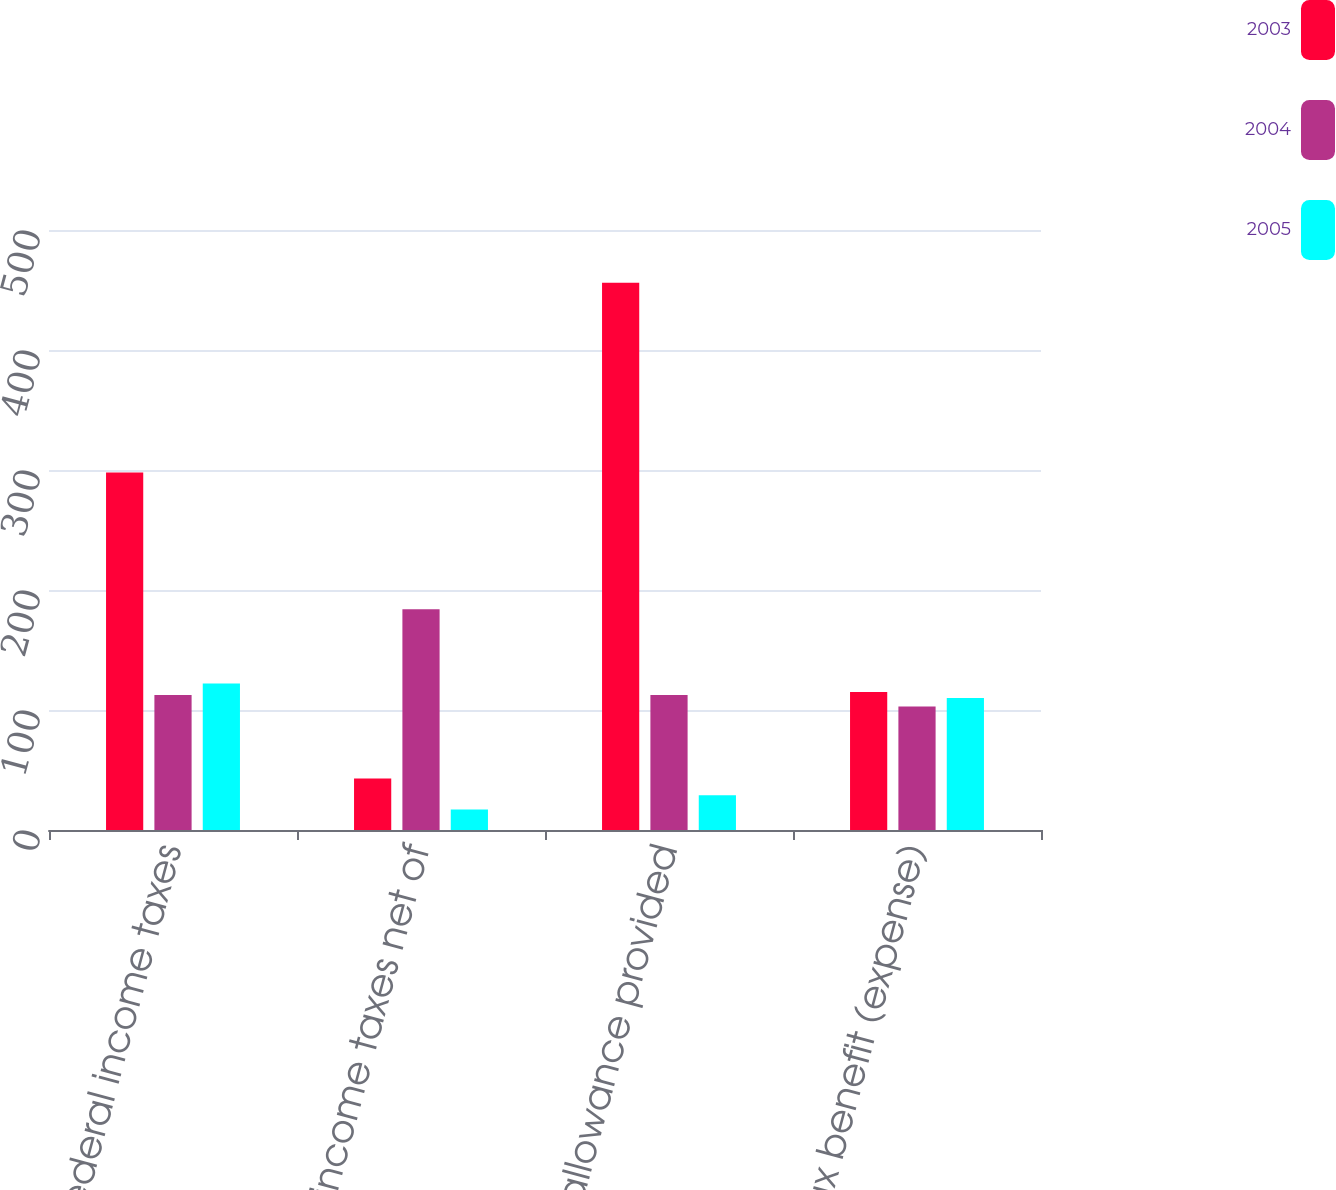Convert chart. <chart><loc_0><loc_0><loc_500><loc_500><stacked_bar_chart><ecel><fcel>Statutory federal income taxes<fcel>State income taxes net of<fcel>Valuation allowance provided<fcel>Income tax benefit (expense)<nl><fcel>2003<fcel>298<fcel>43<fcel>456<fcel>115<nl><fcel>2004<fcel>112.5<fcel>184<fcel>112.5<fcel>103<nl><fcel>2005<fcel>122<fcel>17<fcel>29<fcel>110<nl></chart> 